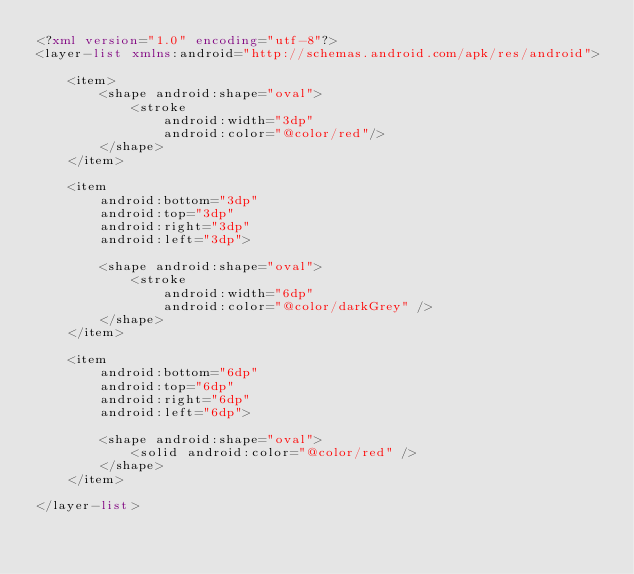Convert code to text. <code><loc_0><loc_0><loc_500><loc_500><_XML_><?xml version="1.0" encoding="utf-8"?>
<layer-list xmlns:android="http://schemas.android.com/apk/res/android">

    <item>
        <shape android:shape="oval">
            <stroke
                android:width="3dp"
                android:color="@color/red"/>
        </shape>
    </item>

    <item
        android:bottom="3dp"
        android:top="3dp"
        android:right="3dp"
        android:left="3dp">

        <shape android:shape="oval">
            <stroke
                android:width="6dp"
                android:color="@color/darkGrey" />
        </shape>
    </item>

    <item
        android:bottom="6dp"
        android:top="6dp"
        android:right="6dp"
        android:left="6dp">

        <shape android:shape="oval">
            <solid android:color="@color/red" />
        </shape>
    </item>

</layer-list></code> 